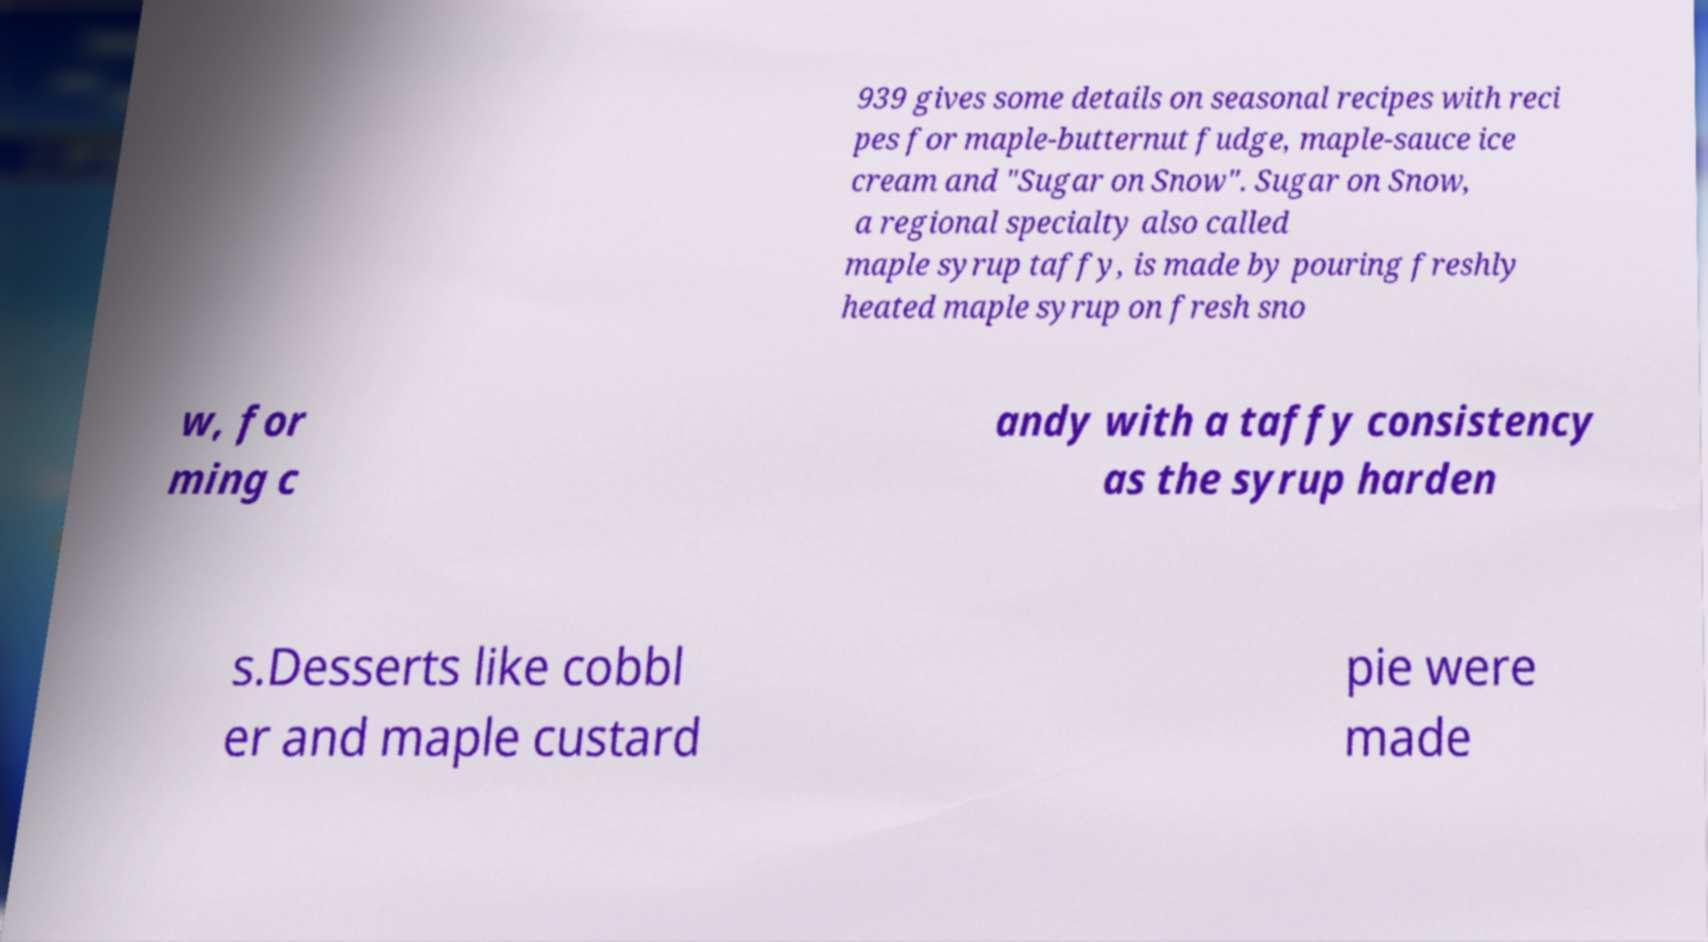Can you read and provide the text displayed in the image?This photo seems to have some interesting text. Can you extract and type it out for me? 939 gives some details on seasonal recipes with reci pes for maple-butternut fudge, maple-sauce ice cream and "Sugar on Snow". Sugar on Snow, a regional specialty also called maple syrup taffy, is made by pouring freshly heated maple syrup on fresh sno w, for ming c andy with a taffy consistency as the syrup harden s.Desserts like cobbl er and maple custard pie were made 